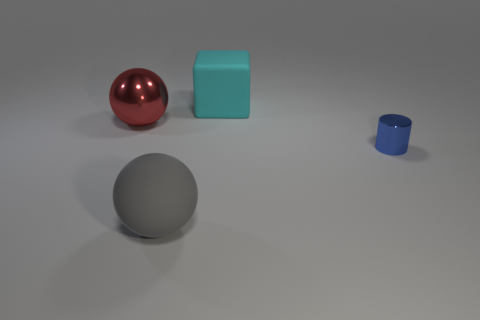How many large matte things are the same color as the small metal cylinder?
Your answer should be compact. 0. Are there the same number of big cyan matte objects in front of the big metallic thing and small blocks?
Provide a succinct answer. Yes. The shiny ball has what color?
Give a very brief answer. Red. There is a sphere that is made of the same material as the tiny thing; what is its size?
Offer a terse response. Large. What color is the thing that is made of the same material as the cyan cube?
Give a very brief answer. Gray. Are there any things that have the same size as the blue shiny cylinder?
Keep it short and to the point. No. What material is the other large object that is the same shape as the gray rubber object?
Offer a very short reply. Metal. The red shiny thing that is the same size as the cyan cube is what shape?
Offer a terse response. Sphere. Is there another object that has the same shape as the gray object?
Make the answer very short. Yes. There is a thing that is behind the ball that is to the left of the big gray thing; what is its shape?
Provide a short and direct response. Cube. 